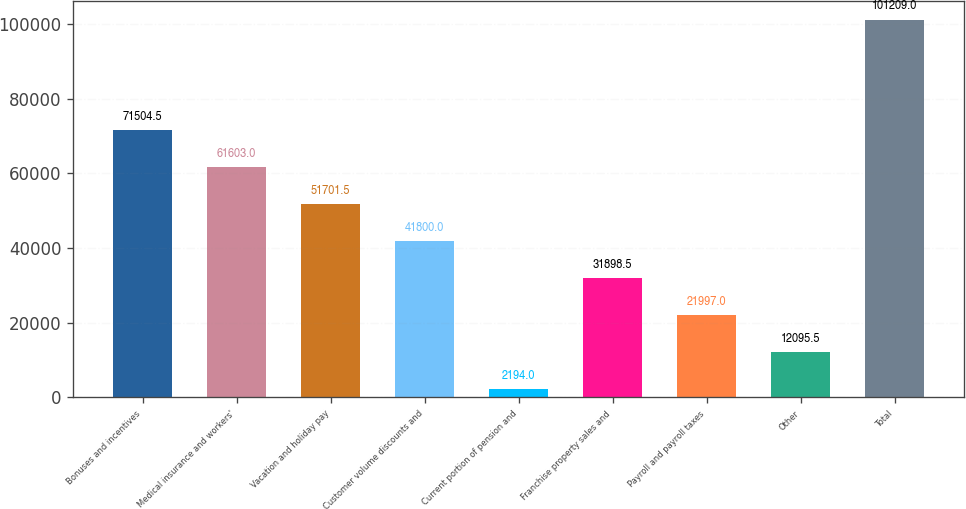<chart> <loc_0><loc_0><loc_500><loc_500><bar_chart><fcel>Bonuses and incentives<fcel>Medical insurance and workers'<fcel>Vacation and holiday pay<fcel>Customer volume discounts and<fcel>Current portion of pension and<fcel>Franchise property sales and<fcel>Payroll and payroll taxes<fcel>Other<fcel>Total<nl><fcel>71504.5<fcel>61603<fcel>51701.5<fcel>41800<fcel>2194<fcel>31898.5<fcel>21997<fcel>12095.5<fcel>101209<nl></chart> 